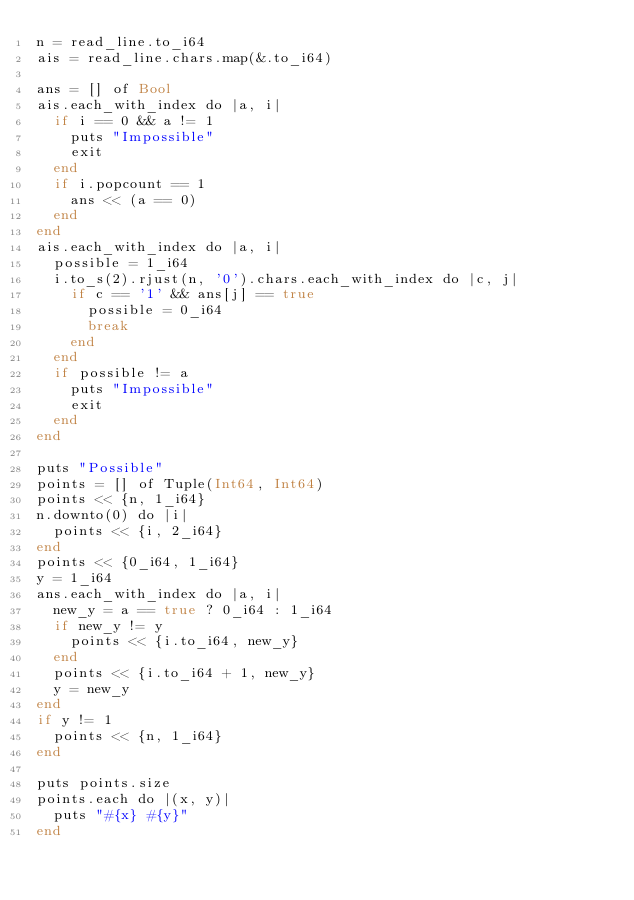Convert code to text. <code><loc_0><loc_0><loc_500><loc_500><_Crystal_>n = read_line.to_i64
ais = read_line.chars.map(&.to_i64)

ans = [] of Bool
ais.each_with_index do |a, i|
  if i == 0 && a != 1
    puts "Impossible"
    exit
  end
  if i.popcount == 1
    ans << (a == 0)
  end
end
ais.each_with_index do |a, i|
  possible = 1_i64
  i.to_s(2).rjust(n, '0').chars.each_with_index do |c, j|
    if c == '1' && ans[j] == true
      possible = 0_i64
      break
    end
  end
  if possible != a
    puts "Impossible"
    exit
  end
end

puts "Possible"
points = [] of Tuple(Int64, Int64)
points << {n, 1_i64}
n.downto(0) do |i|
  points << {i, 2_i64}
end
points << {0_i64, 1_i64}
y = 1_i64
ans.each_with_index do |a, i|
  new_y = a == true ? 0_i64 : 1_i64
  if new_y != y
    points << {i.to_i64, new_y}
  end
  points << {i.to_i64 + 1, new_y}
  y = new_y
end
if y != 1
  points << {n, 1_i64}
end

puts points.size
points.each do |(x, y)|
  puts "#{x} #{y}"
end</code> 